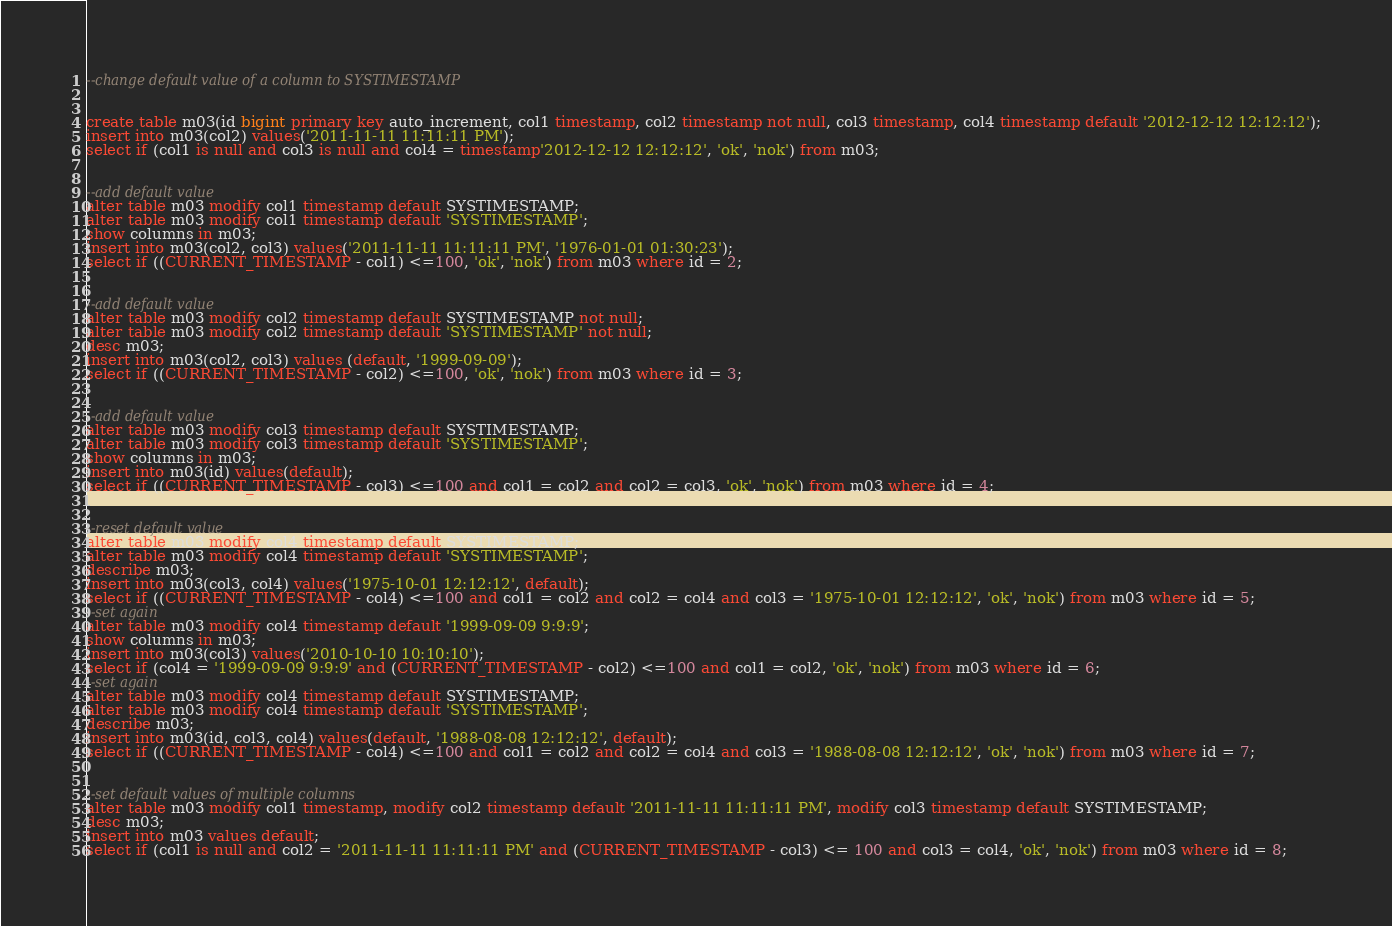<code> <loc_0><loc_0><loc_500><loc_500><_SQL_>--change default value of a column to SYSTIMESTAMP


create table m03(id bigint primary key auto_increment, col1 timestamp, col2 timestamp not null, col3 timestamp, col4 timestamp default '2012-12-12 12:12:12');
insert into m03(col2) values('2011-11-11 11:11:11 PM');
select if (col1 is null and col3 is null and col4 = timestamp'2012-12-12 12:12:12', 'ok', 'nok') from m03;


--add default value
alter table m03 modify col1 timestamp default SYSTIMESTAMP;
alter table m03 modify col1 timestamp default 'SYSTIMESTAMP';
show columns in m03;
insert into m03(col2, col3) values('2011-11-11 11:11:11 PM', '1976-01-01 01:30:23');
select if ((CURRENT_TIMESTAMP - col1) <=100, 'ok', 'nok') from m03 where id = 2;


--add default value
alter table m03 modify col2 timestamp default SYSTIMESTAMP not null;
alter table m03 modify col2 timestamp default 'SYSTIMESTAMP' not null;
desc m03;
insert into m03(col2, col3) values (default, '1999-09-09');
select if ((CURRENT_TIMESTAMP - col2) <=100, 'ok', 'nok') from m03 where id = 3;


--add default value
alter table m03 modify col3 timestamp default SYSTIMESTAMP;
alter table m03 modify col3 timestamp default 'SYSTIMESTAMP';
show columns in m03;
insert into m03(id) values(default);
select if ((CURRENT_TIMESTAMP - col3) <=100 and col1 = col2 and col2 = col3, 'ok', 'nok') from m03 where id = 4;


--reset default value
alter table m03 modify col4 timestamp default SYSTIMESTAMP;
alter table m03 modify col4 timestamp default 'SYSTIMESTAMP';
describe m03;
insert into m03(col3, col4) values('1975-10-01 12:12:12', default);
select if ((CURRENT_TIMESTAMP - col4) <=100 and col1 = col2 and col2 = col4 and col3 = '1975-10-01 12:12:12', 'ok', 'nok') from m03 where id = 5;
--set again
alter table m03 modify col4 timestamp default '1999-09-09 9:9:9';
show columns in m03;
insert into m03(col3) values('2010-10-10 10:10:10');
select if (col4 = '1999-09-09 9:9:9' and (CURRENT_TIMESTAMP - col2) <=100 and col1 = col2, 'ok', 'nok') from m03 where id = 6;
--set again
alter table m03 modify col4 timestamp default SYSTIMESTAMP;
alter table m03 modify col4 timestamp default 'SYSTIMESTAMP';
describe m03;
insert into m03(id, col3, col4) values(default, '1988-08-08 12:12:12', default);
select if ((CURRENT_TIMESTAMP - col4) <=100 and col1 = col2 and col2 = col4 and col3 = '1988-08-08 12:12:12', 'ok', 'nok') from m03 where id = 7;


--set default values of multiple columns
alter table m03 modify col1 timestamp, modify col2 timestamp default '2011-11-11 11:11:11 PM', modify col3 timestamp default SYSTIMESTAMP;
desc m03;
insert into m03 values default;
select if (col1 is null and col2 = '2011-11-11 11:11:11 PM' and (CURRENT_TIMESTAMP - col3) <= 100 and col3 = col4, 'ok', 'nok') from m03 where id = 8;</code> 